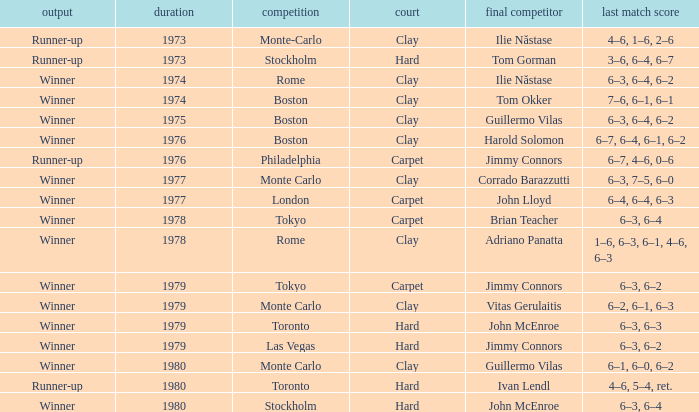I'm looking to parse the entire table for insights. Could you assist me with that? {'header': ['output', 'duration', 'competition', 'court', 'final competitor', 'last match score'], 'rows': [['Runner-up', '1973', 'Monte-Carlo', 'Clay', 'Ilie Năstase', '4–6, 1–6, 2–6'], ['Runner-up', '1973', 'Stockholm', 'Hard', 'Tom Gorman', '3–6, 6–4, 6–7'], ['Winner', '1974', 'Rome', 'Clay', 'Ilie Năstase', '6–3, 6–4, 6–2'], ['Winner', '1974', 'Boston', 'Clay', 'Tom Okker', '7–6, 6–1, 6–1'], ['Winner', '1975', 'Boston', 'Clay', 'Guillermo Vilas', '6–3, 6–4, 6–2'], ['Winner', '1976', 'Boston', 'Clay', 'Harold Solomon', '6–7, 6–4, 6–1, 6–2'], ['Runner-up', '1976', 'Philadelphia', 'Carpet', 'Jimmy Connors', '6–7, 4–6, 0–6'], ['Winner', '1977', 'Monte Carlo', 'Clay', 'Corrado Barazzutti', '6–3, 7–5, 6–0'], ['Winner', '1977', 'London', 'Carpet', 'John Lloyd', '6–4, 6–4, 6–3'], ['Winner', '1978', 'Tokyo', 'Carpet', 'Brian Teacher', '6–3, 6–4'], ['Winner', '1978', 'Rome', 'Clay', 'Adriano Panatta', '1–6, 6–3, 6–1, 4–6, 6–3'], ['Winner', '1979', 'Tokyo', 'Carpet', 'Jimmy Connors', '6–3, 6–2'], ['Winner', '1979', 'Monte Carlo', 'Clay', 'Vitas Gerulaitis', '6–2, 6–1, 6–3'], ['Winner', '1979', 'Toronto', 'Hard', 'John McEnroe', '6–3, 6–3'], ['Winner', '1979', 'Las Vegas', 'Hard', 'Jimmy Connors', '6–3, 6–2'], ['Winner', '1980', 'Monte Carlo', 'Clay', 'Guillermo Vilas', '6–1, 6–0, 6–2'], ['Runner-up', '1980', 'Toronto', 'Hard', 'Ivan Lendl', '4–6, 5–4, ret.'], ['Winner', '1980', 'Stockholm', 'Hard', 'John McEnroe', '6–3, 6–4']]} Name the championship for clay and corrado barazzutti Monte Carlo. 